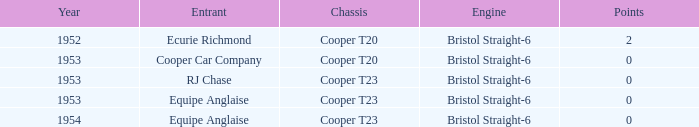Which entrant was present prior to 1953? Ecurie Richmond. Could you parse the entire table as a dict? {'header': ['Year', 'Entrant', 'Chassis', 'Engine', 'Points'], 'rows': [['1952', 'Ecurie Richmond', 'Cooper T20', 'Bristol Straight-6', '2'], ['1953', 'Cooper Car Company', 'Cooper T20', 'Bristol Straight-6', '0'], ['1953', 'RJ Chase', 'Cooper T23', 'Bristol Straight-6', '0'], ['1953', 'Equipe Anglaise', 'Cooper T23', 'Bristol Straight-6', '0'], ['1954', 'Equipe Anglaise', 'Cooper T23', 'Bristol Straight-6', '0']]} 